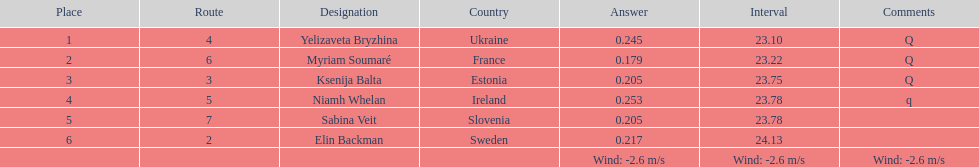Whose time surpasses 2 Elin Backman. 